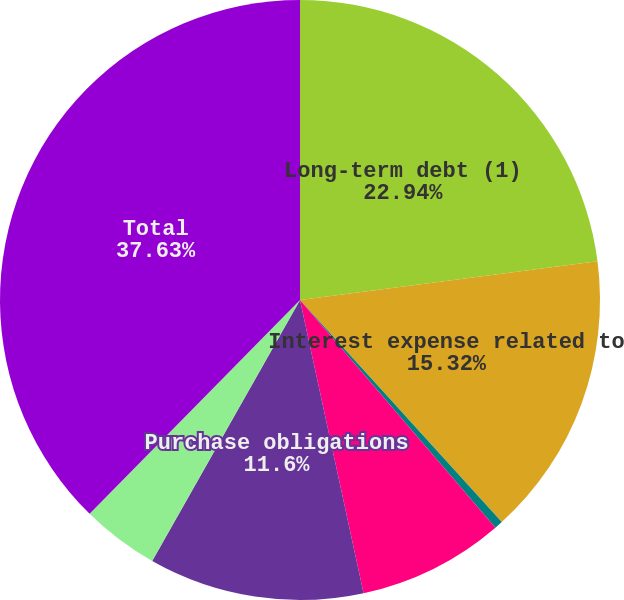Convert chart to OTSL. <chart><loc_0><loc_0><loc_500><loc_500><pie_chart><fcel>Long-term debt (1)<fcel>Interest expense related to<fcel>Reduction of interest expense<fcel>Operating leases<fcel>Purchase obligations<fcel>Other long-term obligations<fcel>Total<nl><fcel>22.94%<fcel>15.32%<fcel>0.45%<fcel>7.89%<fcel>11.6%<fcel>4.17%<fcel>37.63%<nl></chart> 